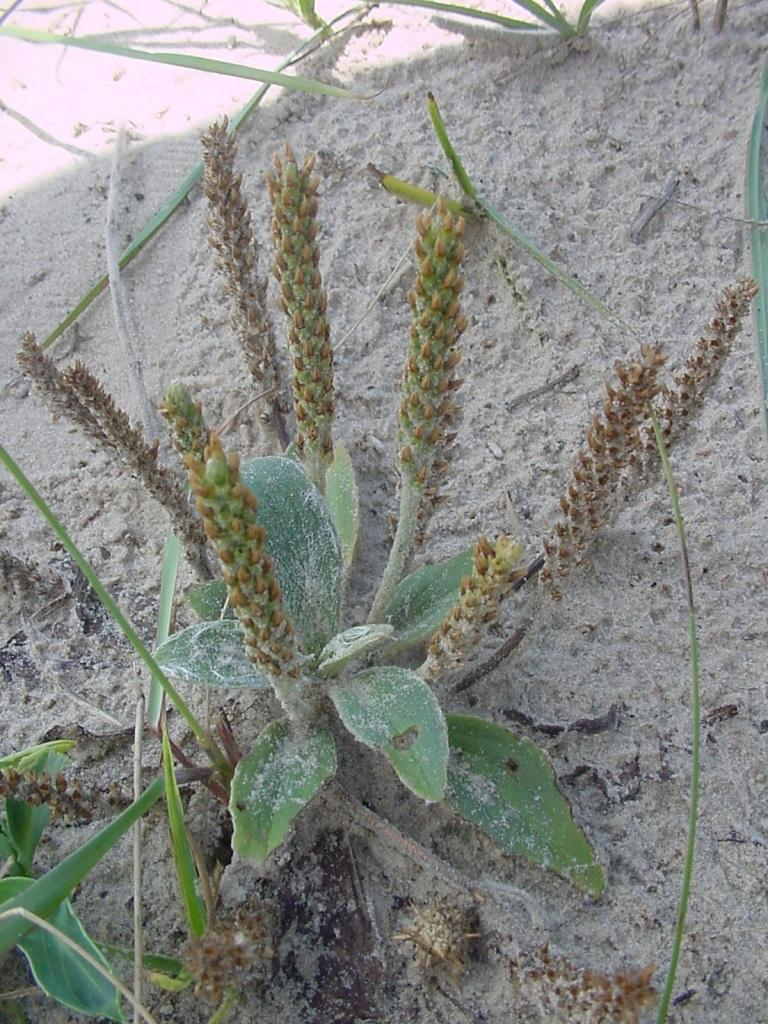What is on the ground in the image? There is a plant on the ground in the image. What is the plant standing in? The plant is in the mud. What color are the leaves of the plant? The leaves of the plant are green. Are there any signs of growth on the plant? Yes, there are buds on the plant. Can you see any snails crawling on the ice in the image? There is no ice or snails present in the image; it features a plant in the mud with green leaves and buds. 